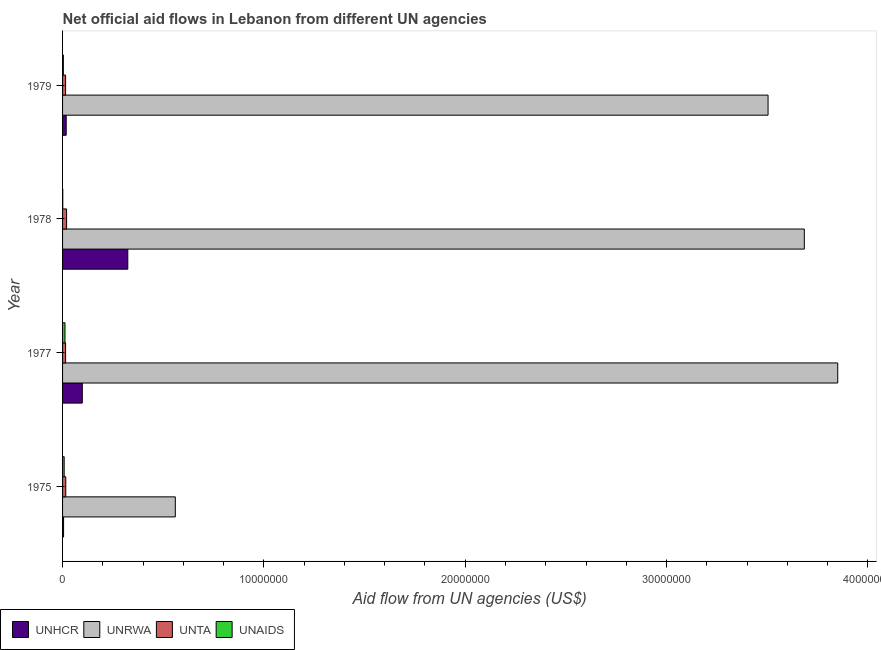How many different coloured bars are there?
Offer a very short reply. 4. How many groups of bars are there?
Your response must be concise. 4. Are the number of bars per tick equal to the number of legend labels?
Make the answer very short. Yes. Are the number of bars on each tick of the Y-axis equal?
Provide a short and direct response. Yes. What is the label of the 4th group of bars from the top?
Your answer should be very brief. 1975. What is the amount of aid given by unrwa in 1975?
Ensure brevity in your answer.  5.60e+06. Across all years, what is the maximum amount of aid given by unaids?
Ensure brevity in your answer.  1.20e+05. Across all years, what is the minimum amount of aid given by unrwa?
Keep it short and to the point. 5.60e+06. In which year was the amount of aid given by unta maximum?
Offer a terse response. 1978. In which year was the amount of aid given by unaids minimum?
Ensure brevity in your answer.  1978. What is the total amount of aid given by unrwa in the graph?
Provide a succinct answer. 1.16e+08. What is the difference between the amount of aid given by unaids in 1978 and that in 1979?
Your answer should be compact. -3.00e+04. What is the difference between the amount of aid given by unhcr in 1975 and the amount of aid given by unta in 1978?
Ensure brevity in your answer.  -1.50e+05. What is the average amount of aid given by unhcr per year?
Give a very brief answer. 1.11e+06. In the year 1978, what is the difference between the amount of aid given by unrwa and amount of aid given by unaids?
Give a very brief answer. 3.68e+07. What is the ratio of the amount of aid given by unrwa in 1978 to that in 1979?
Ensure brevity in your answer.  1.05. Is the amount of aid given by unta in 1975 less than that in 1977?
Offer a terse response. No. Is the difference between the amount of aid given by unhcr in 1975 and 1977 greater than the difference between the amount of aid given by unta in 1975 and 1977?
Offer a terse response. No. What is the difference between the highest and the lowest amount of aid given by unta?
Ensure brevity in your answer.  5.00e+04. Is the sum of the amount of aid given by unhcr in 1975 and 1979 greater than the maximum amount of aid given by unaids across all years?
Make the answer very short. Yes. What does the 4th bar from the top in 1978 represents?
Provide a short and direct response. UNHCR. What does the 2nd bar from the bottom in 1975 represents?
Your answer should be very brief. UNRWA. How many bars are there?
Your answer should be very brief. 16. Are all the bars in the graph horizontal?
Ensure brevity in your answer.  Yes. How many years are there in the graph?
Provide a succinct answer. 4. What is the difference between two consecutive major ticks on the X-axis?
Make the answer very short. 1.00e+07. Does the graph contain any zero values?
Keep it short and to the point. No. Does the graph contain grids?
Ensure brevity in your answer.  No. How many legend labels are there?
Offer a very short reply. 4. What is the title of the graph?
Provide a succinct answer. Net official aid flows in Lebanon from different UN agencies. What is the label or title of the X-axis?
Give a very brief answer. Aid flow from UN agencies (US$). What is the label or title of the Y-axis?
Offer a very short reply. Year. What is the Aid flow from UN agencies (US$) in UNRWA in 1975?
Your answer should be very brief. 5.60e+06. What is the Aid flow from UN agencies (US$) in UNTA in 1975?
Your response must be concise. 1.60e+05. What is the Aid flow from UN agencies (US$) in UNAIDS in 1975?
Keep it short and to the point. 8.00e+04. What is the Aid flow from UN agencies (US$) in UNHCR in 1977?
Provide a short and direct response. 9.80e+05. What is the Aid flow from UN agencies (US$) in UNRWA in 1977?
Make the answer very short. 3.85e+07. What is the Aid flow from UN agencies (US$) in UNTA in 1977?
Offer a terse response. 1.50e+05. What is the Aid flow from UN agencies (US$) of UNHCR in 1978?
Your response must be concise. 3.24e+06. What is the Aid flow from UN agencies (US$) of UNRWA in 1978?
Provide a succinct answer. 3.68e+07. What is the Aid flow from UN agencies (US$) of UNTA in 1978?
Provide a short and direct response. 2.00e+05. What is the Aid flow from UN agencies (US$) in UNHCR in 1979?
Ensure brevity in your answer.  1.80e+05. What is the Aid flow from UN agencies (US$) in UNRWA in 1979?
Keep it short and to the point. 3.50e+07. What is the Aid flow from UN agencies (US$) in UNTA in 1979?
Offer a terse response. 1.50e+05. What is the Aid flow from UN agencies (US$) in UNAIDS in 1979?
Your response must be concise. 4.00e+04. Across all years, what is the maximum Aid flow from UN agencies (US$) of UNHCR?
Make the answer very short. 3.24e+06. Across all years, what is the maximum Aid flow from UN agencies (US$) in UNRWA?
Provide a short and direct response. 3.85e+07. Across all years, what is the maximum Aid flow from UN agencies (US$) of UNTA?
Make the answer very short. 2.00e+05. Across all years, what is the maximum Aid flow from UN agencies (US$) in UNAIDS?
Offer a very short reply. 1.20e+05. Across all years, what is the minimum Aid flow from UN agencies (US$) of UNHCR?
Keep it short and to the point. 5.00e+04. Across all years, what is the minimum Aid flow from UN agencies (US$) in UNRWA?
Provide a succinct answer. 5.60e+06. Across all years, what is the minimum Aid flow from UN agencies (US$) in UNTA?
Offer a very short reply. 1.50e+05. What is the total Aid flow from UN agencies (US$) in UNHCR in the graph?
Provide a succinct answer. 4.45e+06. What is the total Aid flow from UN agencies (US$) of UNRWA in the graph?
Make the answer very short. 1.16e+08. What is the total Aid flow from UN agencies (US$) of UNTA in the graph?
Your answer should be compact. 6.60e+05. What is the difference between the Aid flow from UN agencies (US$) in UNHCR in 1975 and that in 1977?
Give a very brief answer. -9.30e+05. What is the difference between the Aid flow from UN agencies (US$) in UNRWA in 1975 and that in 1977?
Offer a terse response. -3.29e+07. What is the difference between the Aid flow from UN agencies (US$) in UNHCR in 1975 and that in 1978?
Make the answer very short. -3.19e+06. What is the difference between the Aid flow from UN agencies (US$) in UNRWA in 1975 and that in 1978?
Ensure brevity in your answer.  -3.12e+07. What is the difference between the Aid flow from UN agencies (US$) of UNTA in 1975 and that in 1978?
Your response must be concise. -4.00e+04. What is the difference between the Aid flow from UN agencies (US$) in UNHCR in 1975 and that in 1979?
Give a very brief answer. -1.30e+05. What is the difference between the Aid flow from UN agencies (US$) of UNRWA in 1975 and that in 1979?
Make the answer very short. -2.94e+07. What is the difference between the Aid flow from UN agencies (US$) in UNAIDS in 1975 and that in 1979?
Your response must be concise. 4.00e+04. What is the difference between the Aid flow from UN agencies (US$) of UNHCR in 1977 and that in 1978?
Ensure brevity in your answer.  -2.26e+06. What is the difference between the Aid flow from UN agencies (US$) in UNRWA in 1977 and that in 1978?
Offer a terse response. 1.66e+06. What is the difference between the Aid flow from UN agencies (US$) in UNTA in 1977 and that in 1978?
Offer a very short reply. -5.00e+04. What is the difference between the Aid flow from UN agencies (US$) in UNAIDS in 1977 and that in 1978?
Offer a very short reply. 1.10e+05. What is the difference between the Aid flow from UN agencies (US$) of UNRWA in 1977 and that in 1979?
Offer a terse response. 3.46e+06. What is the difference between the Aid flow from UN agencies (US$) of UNAIDS in 1977 and that in 1979?
Your response must be concise. 8.00e+04. What is the difference between the Aid flow from UN agencies (US$) of UNHCR in 1978 and that in 1979?
Your answer should be compact. 3.06e+06. What is the difference between the Aid flow from UN agencies (US$) of UNRWA in 1978 and that in 1979?
Offer a very short reply. 1.80e+06. What is the difference between the Aid flow from UN agencies (US$) of UNAIDS in 1978 and that in 1979?
Provide a succinct answer. -3.00e+04. What is the difference between the Aid flow from UN agencies (US$) in UNHCR in 1975 and the Aid flow from UN agencies (US$) in UNRWA in 1977?
Provide a succinct answer. -3.84e+07. What is the difference between the Aid flow from UN agencies (US$) in UNHCR in 1975 and the Aid flow from UN agencies (US$) in UNTA in 1977?
Keep it short and to the point. -1.00e+05. What is the difference between the Aid flow from UN agencies (US$) of UNHCR in 1975 and the Aid flow from UN agencies (US$) of UNAIDS in 1977?
Offer a very short reply. -7.00e+04. What is the difference between the Aid flow from UN agencies (US$) in UNRWA in 1975 and the Aid flow from UN agencies (US$) in UNTA in 1977?
Your answer should be compact. 5.45e+06. What is the difference between the Aid flow from UN agencies (US$) in UNRWA in 1975 and the Aid flow from UN agencies (US$) in UNAIDS in 1977?
Your answer should be compact. 5.48e+06. What is the difference between the Aid flow from UN agencies (US$) of UNHCR in 1975 and the Aid flow from UN agencies (US$) of UNRWA in 1978?
Give a very brief answer. -3.68e+07. What is the difference between the Aid flow from UN agencies (US$) of UNHCR in 1975 and the Aid flow from UN agencies (US$) of UNTA in 1978?
Your answer should be compact. -1.50e+05. What is the difference between the Aid flow from UN agencies (US$) in UNHCR in 1975 and the Aid flow from UN agencies (US$) in UNAIDS in 1978?
Ensure brevity in your answer.  4.00e+04. What is the difference between the Aid flow from UN agencies (US$) in UNRWA in 1975 and the Aid flow from UN agencies (US$) in UNTA in 1978?
Provide a short and direct response. 5.40e+06. What is the difference between the Aid flow from UN agencies (US$) in UNRWA in 1975 and the Aid flow from UN agencies (US$) in UNAIDS in 1978?
Your answer should be compact. 5.59e+06. What is the difference between the Aid flow from UN agencies (US$) of UNTA in 1975 and the Aid flow from UN agencies (US$) of UNAIDS in 1978?
Make the answer very short. 1.50e+05. What is the difference between the Aid flow from UN agencies (US$) of UNHCR in 1975 and the Aid flow from UN agencies (US$) of UNRWA in 1979?
Keep it short and to the point. -3.50e+07. What is the difference between the Aid flow from UN agencies (US$) in UNRWA in 1975 and the Aid flow from UN agencies (US$) in UNTA in 1979?
Make the answer very short. 5.45e+06. What is the difference between the Aid flow from UN agencies (US$) in UNRWA in 1975 and the Aid flow from UN agencies (US$) in UNAIDS in 1979?
Provide a succinct answer. 5.56e+06. What is the difference between the Aid flow from UN agencies (US$) in UNTA in 1975 and the Aid flow from UN agencies (US$) in UNAIDS in 1979?
Give a very brief answer. 1.20e+05. What is the difference between the Aid flow from UN agencies (US$) in UNHCR in 1977 and the Aid flow from UN agencies (US$) in UNRWA in 1978?
Make the answer very short. -3.59e+07. What is the difference between the Aid flow from UN agencies (US$) of UNHCR in 1977 and the Aid flow from UN agencies (US$) of UNTA in 1978?
Keep it short and to the point. 7.80e+05. What is the difference between the Aid flow from UN agencies (US$) of UNHCR in 1977 and the Aid flow from UN agencies (US$) of UNAIDS in 1978?
Keep it short and to the point. 9.70e+05. What is the difference between the Aid flow from UN agencies (US$) of UNRWA in 1977 and the Aid flow from UN agencies (US$) of UNTA in 1978?
Offer a terse response. 3.83e+07. What is the difference between the Aid flow from UN agencies (US$) of UNRWA in 1977 and the Aid flow from UN agencies (US$) of UNAIDS in 1978?
Make the answer very short. 3.85e+07. What is the difference between the Aid flow from UN agencies (US$) in UNTA in 1977 and the Aid flow from UN agencies (US$) in UNAIDS in 1978?
Offer a terse response. 1.40e+05. What is the difference between the Aid flow from UN agencies (US$) in UNHCR in 1977 and the Aid flow from UN agencies (US$) in UNRWA in 1979?
Keep it short and to the point. -3.41e+07. What is the difference between the Aid flow from UN agencies (US$) of UNHCR in 1977 and the Aid flow from UN agencies (US$) of UNTA in 1979?
Your response must be concise. 8.30e+05. What is the difference between the Aid flow from UN agencies (US$) of UNHCR in 1977 and the Aid flow from UN agencies (US$) of UNAIDS in 1979?
Provide a succinct answer. 9.40e+05. What is the difference between the Aid flow from UN agencies (US$) in UNRWA in 1977 and the Aid flow from UN agencies (US$) in UNTA in 1979?
Provide a short and direct response. 3.84e+07. What is the difference between the Aid flow from UN agencies (US$) of UNRWA in 1977 and the Aid flow from UN agencies (US$) of UNAIDS in 1979?
Give a very brief answer. 3.85e+07. What is the difference between the Aid flow from UN agencies (US$) of UNTA in 1977 and the Aid flow from UN agencies (US$) of UNAIDS in 1979?
Offer a very short reply. 1.10e+05. What is the difference between the Aid flow from UN agencies (US$) of UNHCR in 1978 and the Aid flow from UN agencies (US$) of UNRWA in 1979?
Give a very brief answer. -3.18e+07. What is the difference between the Aid flow from UN agencies (US$) in UNHCR in 1978 and the Aid flow from UN agencies (US$) in UNTA in 1979?
Offer a terse response. 3.09e+06. What is the difference between the Aid flow from UN agencies (US$) of UNHCR in 1978 and the Aid flow from UN agencies (US$) of UNAIDS in 1979?
Provide a short and direct response. 3.20e+06. What is the difference between the Aid flow from UN agencies (US$) of UNRWA in 1978 and the Aid flow from UN agencies (US$) of UNTA in 1979?
Ensure brevity in your answer.  3.67e+07. What is the difference between the Aid flow from UN agencies (US$) of UNRWA in 1978 and the Aid flow from UN agencies (US$) of UNAIDS in 1979?
Your answer should be very brief. 3.68e+07. What is the average Aid flow from UN agencies (US$) in UNHCR per year?
Provide a succinct answer. 1.11e+06. What is the average Aid flow from UN agencies (US$) of UNRWA per year?
Your answer should be compact. 2.90e+07. What is the average Aid flow from UN agencies (US$) in UNTA per year?
Offer a very short reply. 1.65e+05. What is the average Aid flow from UN agencies (US$) in UNAIDS per year?
Your response must be concise. 6.25e+04. In the year 1975, what is the difference between the Aid flow from UN agencies (US$) of UNHCR and Aid flow from UN agencies (US$) of UNRWA?
Give a very brief answer. -5.55e+06. In the year 1975, what is the difference between the Aid flow from UN agencies (US$) of UNHCR and Aid flow from UN agencies (US$) of UNTA?
Provide a succinct answer. -1.10e+05. In the year 1975, what is the difference between the Aid flow from UN agencies (US$) of UNRWA and Aid flow from UN agencies (US$) of UNTA?
Keep it short and to the point. 5.44e+06. In the year 1975, what is the difference between the Aid flow from UN agencies (US$) of UNRWA and Aid flow from UN agencies (US$) of UNAIDS?
Keep it short and to the point. 5.52e+06. In the year 1975, what is the difference between the Aid flow from UN agencies (US$) in UNTA and Aid flow from UN agencies (US$) in UNAIDS?
Offer a very short reply. 8.00e+04. In the year 1977, what is the difference between the Aid flow from UN agencies (US$) of UNHCR and Aid flow from UN agencies (US$) of UNRWA?
Give a very brief answer. -3.75e+07. In the year 1977, what is the difference between the Aid flow from UN agencies (US$) in UNHCR and Aid flow from UN agencies (US$) in UNTA?
Your answer should be compact. 8.30e+05. In the year 1977, what is the difference between the Aid flow from UN agencies (US$) in UNHCR and Aid flow from UN agencies (US$) in UNAIDS?
Ensure brevity in your answer.  8.60e+05. In the year 1977, what is the difference between the Aid flow from UN agencies (US$) in UNRWA and Aid flow from UN agencies (US$) in UNTA?
Offer a terse response. 3.84e+07. In the year 1977, what is the difference between the Aid flow from UN agencies (US$) in UNRWA and Aid flow from UN agencies (US$) in UNAIDS?
Ensure brevity in your answer.  3.84e+07. In the year 1978, what is the difference between the Aid flow from UN agencies (US$) of UNHCR and Aid flow from UN agencies (US$) of UNRWA?
Your answer should be compact. -3.36e+07. In the year 1978, what is the difference between the Aid flow from UN agencies (US$) of UNHCR and Aid flow from UN agencies (US$) of UNTA?
Offer a very short reply. 3.04e+06. In the year 1978, what is the difference between the Aid flow from UN agencies (US$) of UNHCR and Aid flow from UN agencies (US$) of UNAIDS?
Provide a succinct answer. 3.23e+06. In the year 1978, what is the difference between the Aid flow from UN agencies (US$) of UNRWA and Aid flow from UN agencies (US$) of UNTA?
Provide a succinct answer. 3.66e+07. In the year 1978, what is the difference between the Aid flow from UN agencies (US$) of UNRWA and Aid flow from UN agencies (US$) of UNAIDS?
Your answer should be very brief. 3.68e+07. In the year 1979, what is the difference between the Aid flow from UN agencies (US$) in UNHCR and Aid flow from UN agencies (US$) in UNRWA?
Your answer should be very brief. -3.49e+07. In the year 1979, what is the difference between the Aid flow from UN agencies (US$) of UNHCR and Aid flow from UN agencies (US$) of UNTA?
Keep it short and to the point. 3.00e+04. In the year 1979, what is the difference between the Aid flow from UN agencies (US$) of UNHCR and Aid flow from UN agencies (US$) of UNAIDS?
Make the answer very short. 1.40e+05. In the year 1979, what is the difference between the Aid flow from UN agencies (US$) in UNRWA and Aid flow from UN agencies (US$) in UNTA?
Provide a succinct answer. 3.49e+07. In the year 1979, what is the difference between the Aid flow from UN agencies (US$) in UNRWA and Aid flow from UN agencies (US$) in UNAIDS?
Ensure brevity in your answer.  3.50e+07. What is the ratio of the Aid flow from UN agencies (US$) in UNHCR in 1975 to that in 1977?
Your answer should be compact. 0.05. What is the ratio of the Aid flow from UN agencies (US$) in UNRWA in 1975 to that in 1977?
Offer a terse response. 0.15. What is the ratio of the Aid flow from UN agencies (US$) in UNTA in 1975 to that in 1977?
Ensure brevity in your answer.  1.07. What is the ratio of the Aid flow from UN agencies (US$) of UNAIDS in 1975 to that in 1977?
Your answer should be very brief. 0.67. What is the ratio of the Aid flow from UN agencies (US$) of UNHCR in 1975 to that in 1978?
Ensure brevity in your answer.  0.02. What is the ratio of the Aid flow from UN agencies (US$) of UNRWA in 1975 to that in 1978?
Make the answer very short. 0.15. What is the ratio of the Aid flow from UN agencies (US$) in UNAIDS in 1975 to that in 1978?
Ensure brevity in your answer.  8. What is the ratio of the Aid flow from UN agencies (US$) of UNHCR in 1975 to that in 1979?
Offer a very short reply. 0.28. What is the ratio of the Aid flow from UN agencies (US$) in UNRWA in 1975 to that in 1979?
Provide a short and direct response. 0.16. What is the ratio of the Aid flow from UN agencies (US$) of UNTA in 1975 to that in 1979?
Provide a succinct answer. 1.07. What is the ratio of the Aid flow from UN agencies (US$) of UNAIDS in 1975 to that in 1979?
Give a very brief answer. 2. What is the ratio of the Aid flow from UN agencies (US$) of UNHCR in 1977 to that in 1978?
Your response must be concise. 0.3. What is the ratio of the Aid flow from UN agencies (US$) in UNRWA in 1977 to that in 1978?
Give a very brief answer. 1.05. What is the ratio of the Aid flow from UN agencies (US$) of UNTA in 1977 to that in 1978?
Make the answer very short. 0.75. What is the ratio of the Aid flow from UN agencies (US$) of UNHCR in 1977 to that in 1979?
Provide a short and direct response. 5.44. What is the ratio of the Aid flow from UN agencies (US$) in UNRWA in 1977 to that in 1979?
Keep it short and to the point. 1.1. What is the ratio of the Aid flow from UN agencies (US$) in UNTA in 1977 to that in 1979?
Your answer should be compact. 1. What is the ratio of the Aid flow from UN agencies (US$) of UNAIDS in 1977 to that in 1979?
Provide a succinct answer. 3. What is the ratio of the Aid flow from UN agencies (US$) of UNRWA in 1978 to that in 1979?
Ensure brevity in your answer.  1.05. What is the ratio of the Aid flow from UN agencies (US$) of UNTA in 1978 to that in 1979?
Make the answer very short. 1.33. What is the difference between the highest and the second highest Aid flow from UN agencies (US$) of UNHCR?
Ensure brevity in your answer.  2.26e+06. What is the difference between the highest and the second highest Aid flow from UN agencies (US$) in UNRWA?
Your response must be concise. 1.66e+06. What is the difference between the highest and the second highest Aid flow from UN agencies (US$) in UNTA?
Provide a succinct answer. 4.00e+04. What is the difference between the highest and the second highest Aid flow from UN agencies (US$) in UNAIDS?
Give a very brief answer. 4.00e+04. What is the difference between the highest and the lowest Aid flow from UN agencies (US$) of UNHCR?
Your answer should be compact. 3.19e+06. What is the difference between the highest and the lowest Aid flow from UN agencies (US$) in UNRWA?
Make the answer very short. 3.29e+07. What is the difference between the highest and the lowest Aid flow from UN agencies (US$) of UNTA?
Make the answer very short. 5.00e+04. 